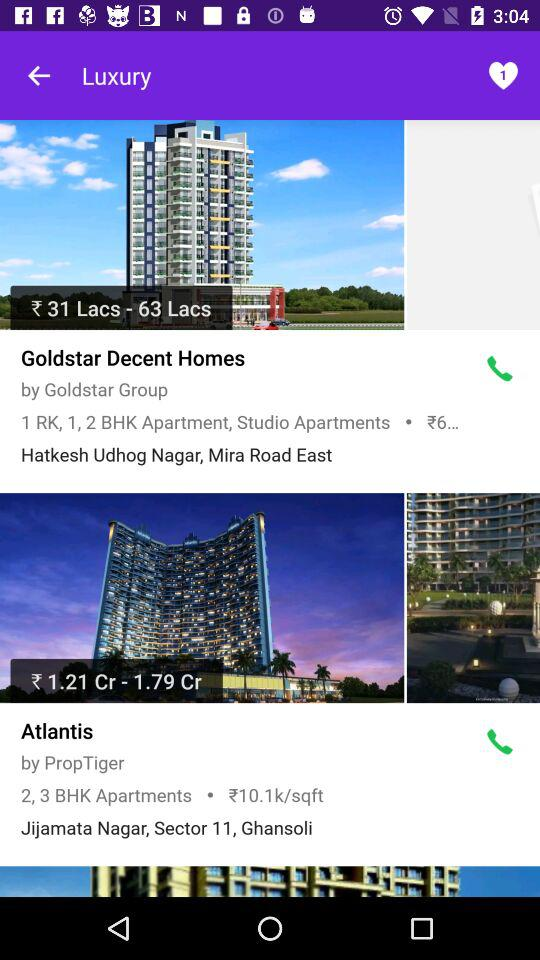What is the location of "Atlantis"? The location is Jijamata Nagar, Sector 11, Ghansoli. 